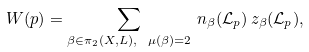<formula> <loc_0><loc_0><loc_500><loc_500>W ( p ) = \sum _ { \beta \in \pi _ { 2 } ( X , L ) , \ \mu ( \beta ) = 2 } \, n _ { \beta } ( \mathcal { L } _ { p } ) \, z _ { \beta } ( \mathcal { L } _ { p } ) ,</formula> 